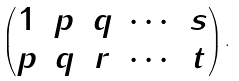Convert formula to latex. <formula><loc_0><loc_0><loc_500><loc_500>\begin{pmatrix} 1 & p & q & \cdots & s \\ p & q & r & \cdots & t \end{pmatrix} .</formula> 